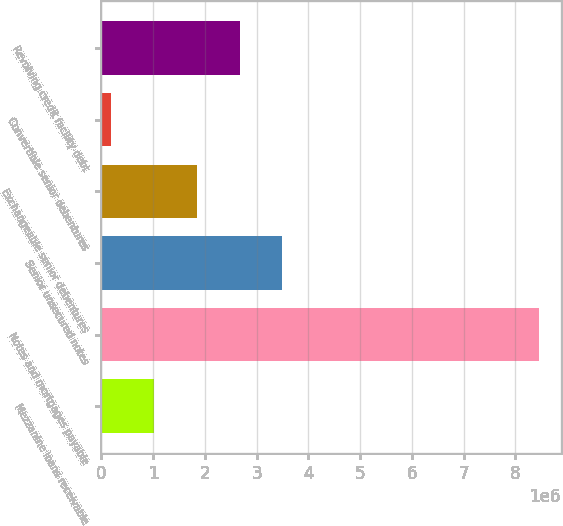<chart> <loc_0><loc_0><loc_500><loc_500><bar_chart><fcel>Mezzanine loans receivable<fcel>Notes and mortgages payable<fcel>Senior unsecured notes<fcel>Exchangeable senior debentures<fcel>Convertible senior debentures<fcel>Revolving credit facility debt<nl><fcel>1.01744e+06<fcel>8.45081e+06<fcel>3.49523e+06<fcel>1.84337e+06<fcel>191510<fcel>2.6693e+06<nl></chart> 